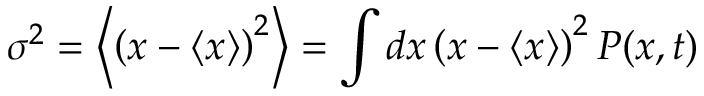<formula> <loc_0><loc_0><loc_500><loc_500>\sigma ^ { 2 } = \left \langle \left ( x - \langle x \rangle \right ) ^ { 2 } \right \rangle = \int d x \left ( x - \langle x \rangle \right ) ^ { 2 } P ( x , t )</formula> 